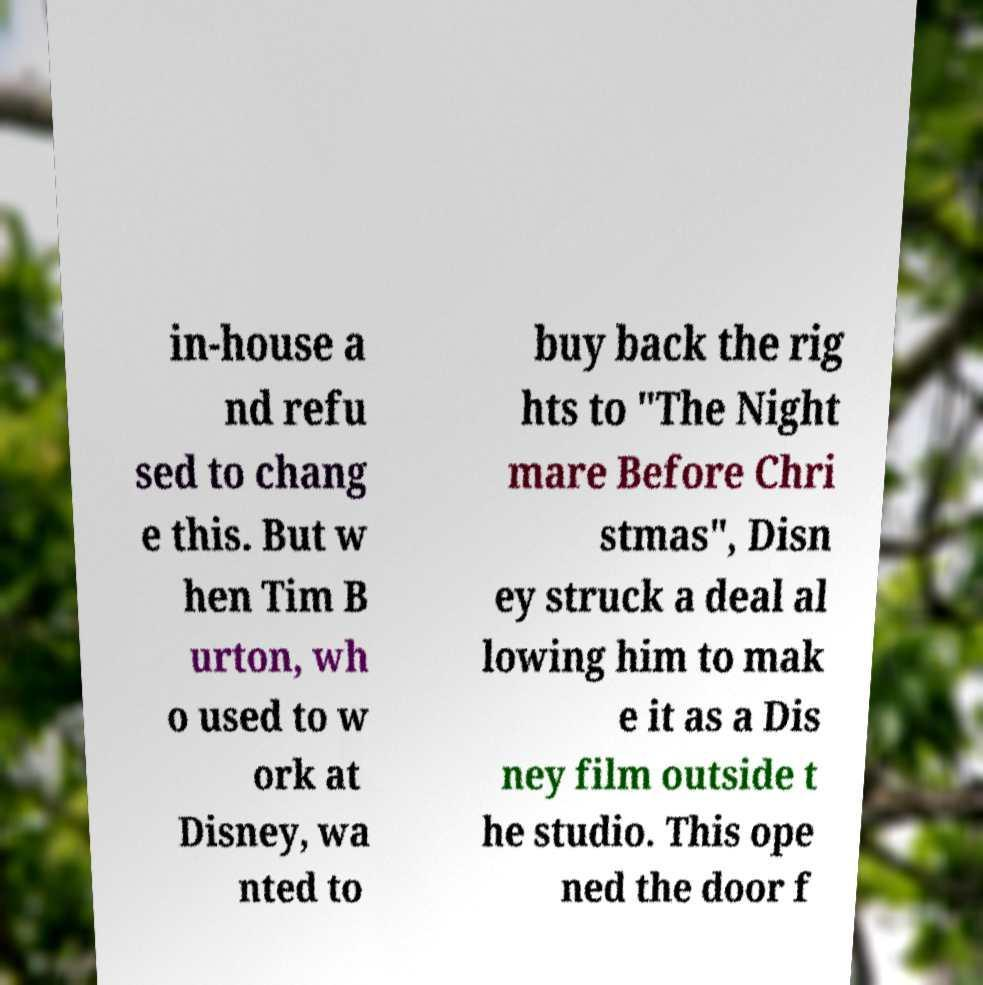Could you extract and type out the text from this image? in-house a nd refu sed to chang e this. But w hen Tim B urton, wh o used to w ork at Disney, wa nted to buy back the rig hts to "The Night mare Before Chri stmas", Disn ey struck a deal al lowing him to mak e it as a Dis ney film outside t he studio. This ope ned the door f 